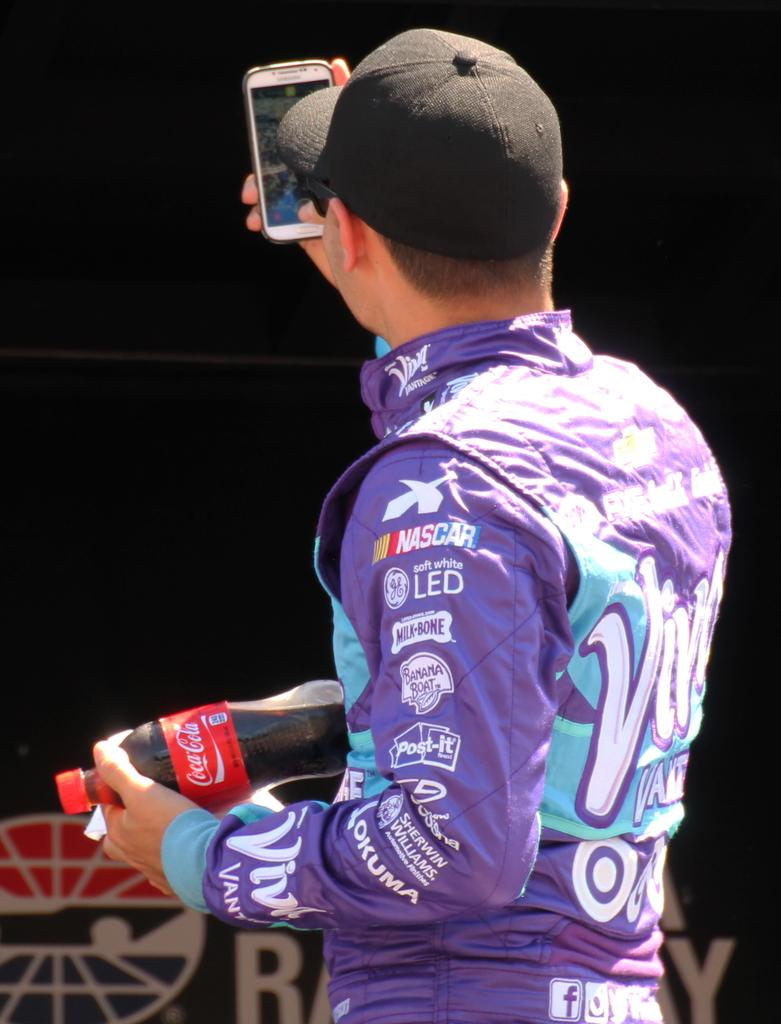<image>
Create a compact narrative representing the image presented. The man wearing the purple shirt is holding a Coca-Cola bottle 